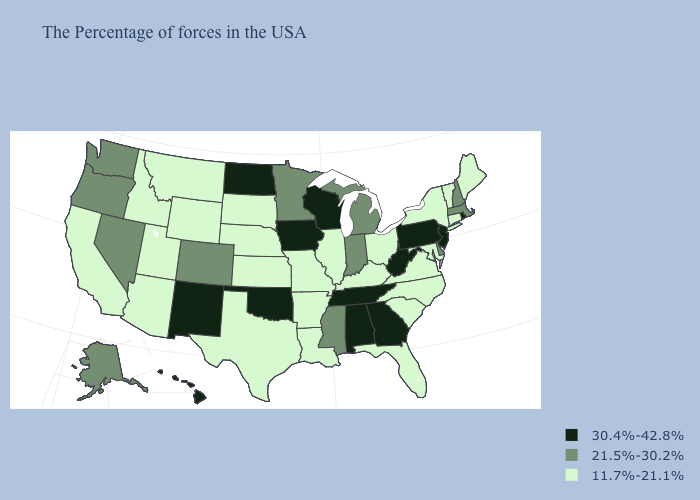What is the value of Missouri?
Keep it brief. 11.7%-21.1%. Name the states that have a value in the range 11.7%-21.1%?
Give a very brief answer. Maine, Vermont, Connecticut, New York, Maryland, Virginia, North Carolina, South Carolina, Ohio, Florida, Kentucky, Illinois, Louisiana, Missouri, Arkansas, Kansas, Nebraska, Texas, South Dakota, Wyoming, Utah, Montana, Arizona, Idaho, California. Name the states that have a value in the range 21.5%-30.2%?
Keep it brief. Massachusetts, New Hampshire, Delaware, Michigan, Indiana, Mississippi, Minnesota, Colorado, Nevada, Washington, Oregon, Alaska. Does Missouri have a lower value than South Carolina?
Short answer required. No. What is the value of Michigan?
Short answer required. 21.5%-30.2%. Does California have the highest value in the West?
Give a very brief answer. No. Which states have the lowest value in the USA?
Write a very short answer. Maine, Vermont, Connecticut, New York, Maryland, Virginia, North Carolina, South Carolina, Ohio, Florida, Kentucky, Illinois, Louisiana, Missouri, Arkansas, Kansas, Nebraska, Texas, South Dakota, Wyoming, Utah, Montana, Arizona, Idaho, California. What is the highest value in states that border Massachusetts?
Quick response, please. 30.4%-42.8%. Among the states that border Oregon , does Washington have the lowest value?
Be succinct. No. Does the first symbol in the legend represent the smallest category?
Write a very short answer. No. What is the lowest value in the MidWest?
Short answer required. 11.7%-21.1%. Name the states that have a value in the range 21.5%-30.2%?
Be succinct. Massachusetts, New Hampshire, Delaware, Michigan, Indiana, Mississippi, Minnesota, Colorado, Nevada, Washington, Oregon, Alaska. Does the first symbol in the legend represent the smallest category?
Short answer required. No. Name the states that have a value in the range 11.7%-21.1%?
Concise answer only. Maine, Vermont, Connecticut, New York, Maryland, Virginia, North Carolina, South Carolina, Ohio, Florida, Kentucky, Illinois, Louisiana, Missouri, Arkansas, Kansas, Nebraska, Texas, South Dakota, Wyoming, Utah, Montana, Arizona, Idaho, California. What is the value of Alaska?
Write a very short answer. 21.5%-30.2%. 